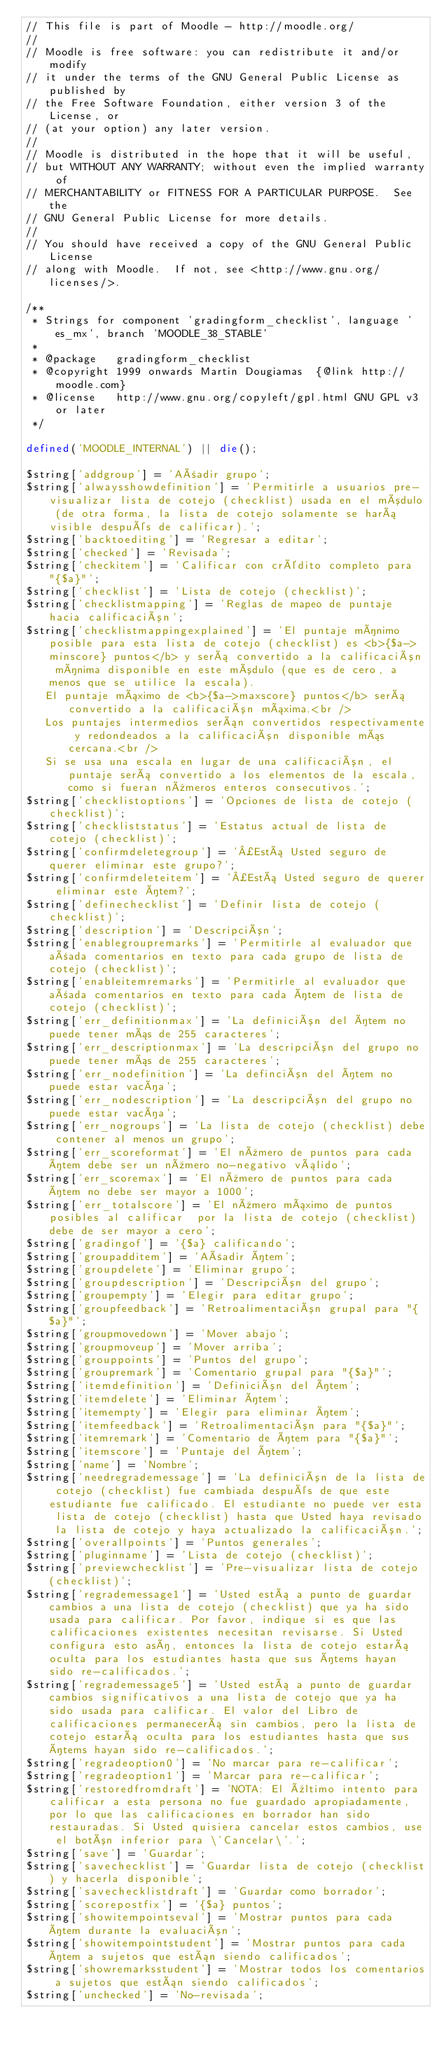Convert code to text. <code><loc_0><loc_0><loc_500><loc_500><_PHP_>// This file is part of Moodle - http://moodle.org/
//
// Moodle is free software: you can redistribute it and/or modify
// it under the terms of the GNU General Public License as published by
// the Free Software Foundation, either version 3 of the License, or
// (at your option) any later version.
//
// Moodle is distributed in the hope that it will be useful,
// but WITHOUT ANY WARRANTY; without even the implied warranty of
// MERCHANTABILITY or FITNESS FOR A PARTICULAR PURPOSE.  See the
// GNU General Public License for more details.
//
// You should have received a copy of the GNU General Public License
// along with Moodle.  If not, see <http://www.gnu.org/licenses/>.

/**
 * Strings for component 'gradingform_checklist', language 'es_mx', branch 'MOODLE_38_STABLE'
 *
 * @package   gradingform_checklist
 * @copyright 1999 onwards Martin Dougiamas  {@link http://moodle.com}
 * @license   http://www.gnu.org/copyleft/gpl.html GNU GPL v3 or later
 */

defined('MOODLE_INTERNAL') || die();

$string['addgroup'] = 'Añadir grupo';
$string['alwaysshowdefinition'] = 'Permitirle a usuarios pre-visualizar lista de cotejo (checklist) usada en el módulo (de otra forma, la lista de cotejo solamente se hará visible después de calificar).';
$string['backtoediting'] = 'Regresar a editar';
$string['checked'] = 'Revisada';
$string['checkitem'] = 'Calificar con crédito completo para "{$a}"';
$string['checklist'] = 'Lista de cotejo (checklist)';
$string['checklistmapping'] = 'Reglas de mapeo de puntaje hacia calificación';
$string['checklistmappingexplained'] = 'El puntaje mínimo posible para esta lista de cotejo (checklist) es <b>{$a->minscore} puntos</b> y será convertido a la calificación mínima disponible en este módulo (que es de cero, a menos que se utilice la escala).
   El puntaje máximo de <b>{$a->maxscore} puntos</b> será convertido a la calificación máxima.<br />
   Los puntajes intermedios serán convertidos respectivamente y redondeados a la calificación disponible más cercana.<br />
   Si se usa una escala en lugar de una calificación, el puntaje será convertido a los elementos de la escala, como si fueran números enteros consecutivos.';
$string['checklistoptions'] = 'Opciones de lista de cotejo (checklist)';
$string['checkliststatus'] = 'Estatus actual de lista de cotejo (checklist)';
$string['confirmdeletegroup'] = '¿Está Usted seguro de querer eliminar este grupo?';
$string['confirmdeleteitem'] = '¿Está Usted seguro de querer eliminar este ítem?';
$string['definechecklist'] = 'Definir lista de cotejo (checklist)';
$string['description'] = 'Descripción';
$string['enablegroupremarks'] = 'Permitirle al evaluador que añada comentarios en texto para cada grupo de lista de cotejo (checklist)';
$string['enableitemremarks'] = 'Permitirle al evaluador que añada comentarios en texto para cada ítem de lista de cotejo (checklist)';
$string['err_definitionmax'] = 'La definición del ítem no puede tener más de 255 caracteres';
$string['err_descriptionmax'] = 'La descripción del grupo no puede tener más de 255 caracteres';
$string['err_nodefinition'] = 'La definción del ítem no puede estar vacía';
$string['err_nodescription'] = 'La descripción del grupo no puede estar vacía';
$string['err_nogroups'] = 'La lista de cotejo (checklist) debe contener al menos un grupo';
$string['err_scoreformat'] = 'El número de puntos para cada ítem debe ser un número no-negativo válido';
$string['err_scoremax'] = 'El número de puntos para cada ítem no debe ser mayor a 1000';
$string['err_totalscore'] = 'El número máximo de puntos posibles al calificar  por la lista de cotejo (checklist) debe de ser mayor a cero';
$string['gradingof'] = '{$a} calificando';
$string['groupadditem'] = 'Añadir ítem';
$string['groupdelete'] = 'Eliminar grupo';
$string['groupdescription'] = 'Descripción del grupo';
$string['groupempty'] = 'Elegir para editar grupo';
$string['groupfeedback'] = 'Retroalimentación grupal para "{$a}"';
$string['groupmovedown'] = 'Mover abajo';
$string['groupmoveup'] = 'Mover arriba';
$string['grouppoints'] = 'Puntos del grupo';
$string['groupremark'] = 'Comentario grupal para "{$a}"';
$string['itemdefinition'] = 'Definición del ítem';
$string['itemdelete'] = 'Eliminar ítem';
$string['itemempty'] = 'Elegir para eliminar ítem';
$string['itemfeedback'] = 'Retroalimentación para "{$a}"';
$string['itemremark'] = 'Comentario de ítem para "{$a}"';
$string['itemscore'] = 'Puntaje del ítem';
$string['name'] = 'Nombre';
$string['needregrademessage'] = 'La definición de la lista de cotejo (checklist) fue cambiada después de que este estudiante fue calificado. El estudiante no puede ver esta lista de cotejo (checklist) hasta que Usted haya revisado la lista de cotejo y haya actualizado la calificación.';
$string['overallpoints'] = 'Puntos generales';
$string['pluginname'] = 'Lista de cotejo (checklist)';
$string['previewchecklist'] = 'Pre-visualizar lista de cotejo (checklist)';
$string['regrademessage1'] = 'Usted está a punto de guardar cambios a una lista de cotejo (checklist) que ya ha sido usada para calificar. Por favor, indique si es que las calificaciones existentes necesitan revisarse. Si Usted configura esto así, entonces la lista de cotejo estará oculta para los estudiantes hasta que sus ítems hayan sido re-calificados.';
$string['regrademessage5'] = 'Usted está a punto de guardar cambios significativos a una lista de cotejo que ya ha sido usada para calificar. El valor del Libro de calificaciones permanecerá sin cambios, pero la lista de cotejo estará oculta para los estudiantes hasta que sus ítems hayan sido re-calificados.';
$string['regradeoption0'] = 'No marcar para re-calificar';
$string['regradeoption1'] = 'Marcar para re-calificar';
$string['restoredfromdraft'] = 'NOTA: El último intento para calificar a esta persona no fue guardado apropiadamente, por lo que las calificaciones en borrador han sido restauradas. Si Usted quisiera cancelar estos cambios, use el botón inferior para \'Cancelar\'.';
$string['save'] = 'Guardar';
$string['savechecklist'] = 'Guardar lista de cotejo (checklist) y hacerla disponible';
$string['savechecklistdraft'] = 'Guardar como borrador';
$string['scorepostfix'] = '{$a} puntos';
$string['showitempointseval'] = 'Mostrar puntos para cada ítem durante la evaluación';
$string['showitempointstudent'] = 'Mostrar puntos para cada ítem a sujetos que están siendo calificados';
$string['showremarksstudent'] = 'Mostrar todos los comentarios a sujetos que están siendo calificados';
$string['unchecked'] = 'No-revisada';
</code> 